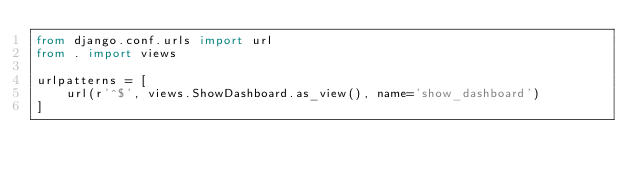<code> <loc_0><loc_0><loc_500><loc_500><_Python_>from django.conf.urls import url
from . import views

urlpatterns = [
    url(r'^$', views.ShowDashboard.as_view(), name='show_dashboard')
]
</code> 